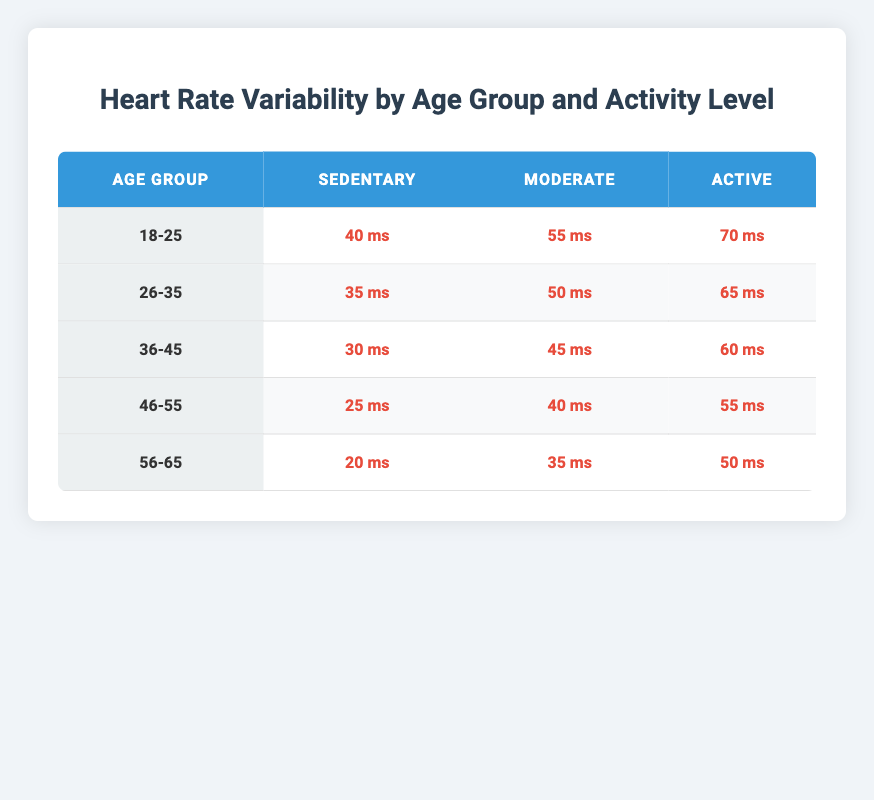What is the heart rate variability for the age group 36-45 in a sedentary state? The table shows the heart rate variability for the age group 36-45 in a sedentary state as 30 ms.
Answer: 30 ms Which activity level has the highest heart rate variability in the 18-25 age group? In the 18-25 age group, the activity level with the highest heart rate variability is 'Active,' with a value of 70 ms.
Answer: Active: 70 ms What is the heart rate variability difference between 'Sedentary' and 'Active' for the age group 46-55? For the age group 46-55, the heart rate variability is 25 ms in a sedentary state and 55 ms in an active state. The difference is calculated as 55 ms - 25 ms = 30 ms.
Answer: 30 ms Is the heart rate variability for 'Moderate' activity in the 56-65 age group greater than for 'Sedentary' activity in the same group? In the 56-65 age group, the heart rate variability for 'Moderate' is 35 ms and for 'Sedentary' is 20 ms. Since 35 ms is greater than 20 ms, the answer is yes.
Answer: Yes What is the average heart rate variability for the age group 26-35? The heart rate variability values for age group 26-35 are 35 ms (Sedentary), 50 ms (Moderate), and 65 ms (Active). To find the average, we sum them up: 35 + 50 + 65 = 150 ms. There are 3 values, so the average is 150 ms / 3 = 50 ms.
Answer: 50 ms What is the lowest heart rate variability recorded across all age groups and activity levels? Scanning through the table, the lowest value recorded is 20 ms for the 'Sedentary' activity in the age group 56-65.
Answer: 20 ms Does the heart rate variability increase consistently across all activity levels for the age group 18-25? For the age group 18-25, the heart rate variability values are 40 ms (Sedentary), 55 ms (Moderate), and 70 ms (Active). Since these values are in ascending order, the answer is yes.
Answer: Yes What is the sum of heart rate variability for 'Active' across all age groups? The heart rate variability values for 'Active' across all age groups are 70 ms (18-25), 65 ms (26-35), 60 ms (36-45), 55 ms (46-55), and 50 ms (56-65). Adding them together gives us 70 + 65 + 60 + 55 + 50 = 300 ms.
Answer: 300 ms What activity level has the lowest heart rate variability in the age group 36-45? Looking at the age group 36-45, the heart rate variability values are 30 ms (Sedentary), 45 ms (Moderate), and 60 ms (Active). The lowest value is 30 ms, which corresponds to the 'Sedentary' activity level.
Answer: Sedentary: 30 ms 